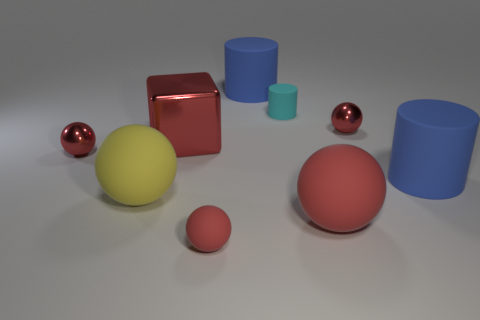Subtract all cyan cubes. How many red spheres are left? 4 Subtract all big red spheres. How many spheres are left? 4 Subtract all yellow balls. How many balls are left? 4 Subtract all cyan spheres. Subtract all blue cylinders. How many spheres are left? 5 Subtract all cylinders. How many objects are left? 6 Add 3 large blue things. How many large blue things exist? 5 Subtract 0 gray spheres. How many objects are left? 9 Subtract all large blue matte objects. Subtract all blue objects. How many objects are left? 5 Add 7 small matte cylinders. How many small matte cylinders are left? 8 